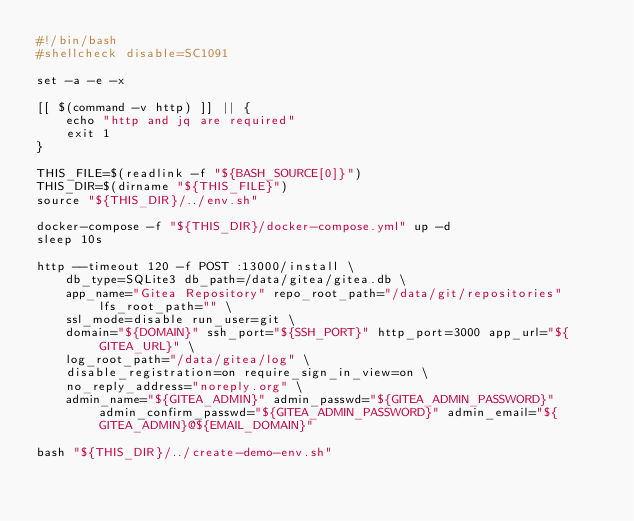<code> <loc_0><loc_0><loc_500><loc_500><_Bash_>#!/bin/bash
#shellcheck disable=SC1091

set -a -e -x

[[ $(command -v http) ]] || {
    echo "http and jq are required"
    exit 1
}

THIS_FILE=$(readlink -f "${BASH_SOURCE[0]}")
THIS_DIR=$(dirname "${THIS_FILE}")
source "${THIS_DIR}/../env.sh"

docker-compose -f "${THIS_DIR}/docker-compose.yml" up -d
sleep 10s

http --timeout 120 -f POST :13000/install \
    db_type=SQLite3 db_path=/data/gitea/gitea.db \
    app_name="Gitea Repository" repo_root_path="/data/git/repositories" lfs_root_path="" \
    ssl_mode=disable run_user=git \
    domain="${DOMAIN}" ssh_port="${SSH_PORT}" http_port=3000 app_url="${GITEA_URL}" \
    log_root_path="/data/gitea/log" \
    disable_registration=on require_sign_in_view=on \
    no_reply_address="noreply.org" \
    admin_name="${GITEA_ADMIN}" admin_passwd="${GITEA_ADMIN_PASSWORD}" admin_confirm_passwd="${GITEA_ADMIN_PASSWORD}" admin_email="${GITEA_ADMIN}@${EMAIL_DOMAIN}"

bash "${THIS_DIR}/../create-demo-env.sh"
</code> 